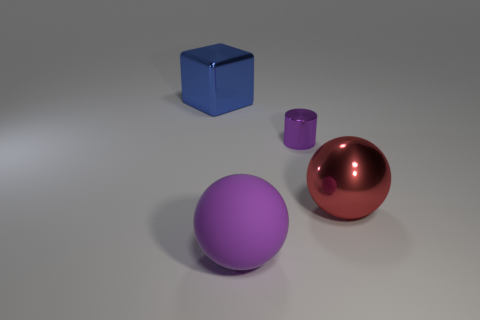What can you infer about the objects' sizes relative to each other? Comparing the objects in the image, the red ball appears to be the largest, followed by the blue cube, while the purple cylinder seems to be the smallest. The differences in size may not represent their real-life proportions, as perspective and camera positioning can distort the perception of scale.  Do these objects serve a practical purpose or are they purely decorative? Without additional context, it's difficult to determine their intended purpose. However, the objects appear to be more representative or aesthetic in nature, perhaps used for artistic or illustrative purposes, rather than functional objects with a specific utility. 